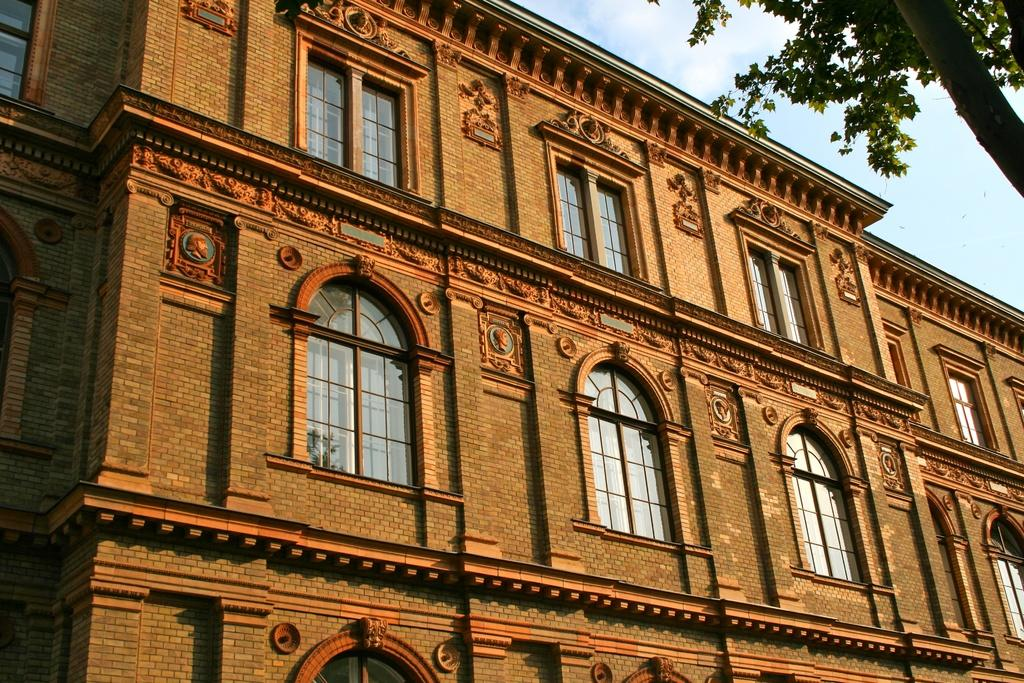What type of structure is present in the image? There is a building in the image. What feature of the building is mentioned in the facts? The building has many windows. What natural element is present in the image? There is a tree in the image. What part of the natural environment is visible in the image? The sky is visible in the image. What additional detail can be observed on the windows of the building? There is a reflection of a tree on the window glass. Can you see a ghost flying a kite in the image? No, there is no ghost or kite present in the image. 